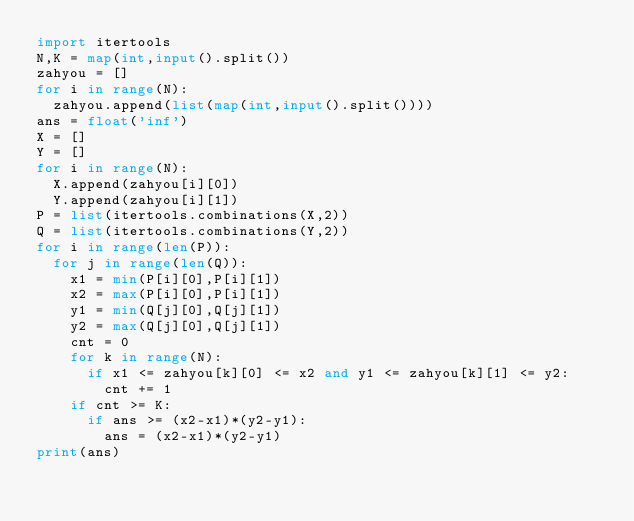<code> <loc_0><loc_0><loc_500><loc_500><_Python_>import itertools
N,K = map(int,input().split())
zahyou = []
for i in range(N):
  zahyou.append(list(map(int,input().split())))
ans = float('inf')
X = []
Y = []
for i in range(N):
  X.append(zahyou[i][0])
  Y.append(zahyou[i][1])
P = list(itertools.combinations(X,2))
Q = list(itertools.combinations(Y,2))
for i in range(len(P)):
  for j in range(len(Q)):
    x1 = min(P[i][0],P[i][1])
    x2 = max(P[i][0],P[i][1])
    y1 = min(Q[j][0],Q[j][1])
    y2 = max(Q[j][0],Q[j][1])
    cnt = 0
    for k in range(N):
      if x1 <= zahyou[k][0] <= x2 and y1 <= zahyou[k][1] <= y2:
        cnt += 1
    if cnt >= K:
      if ans >= (x2-x1)*(y2-y1):
        ans = (x2-x1)*(y2-y1)
print(ans)</code> 